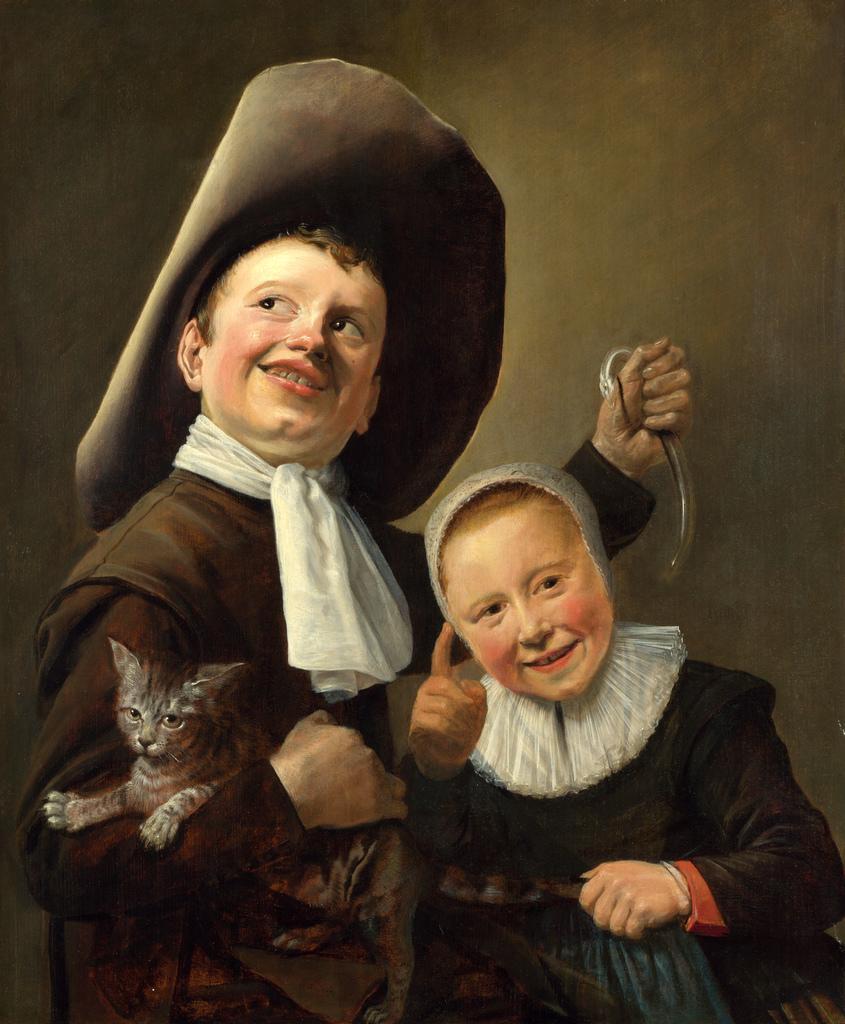Could you give a brief overview of what you see in this image? In this image I can see the painting of two persons. I can see a person is holding a cat. I can see the brown and black colored background. 